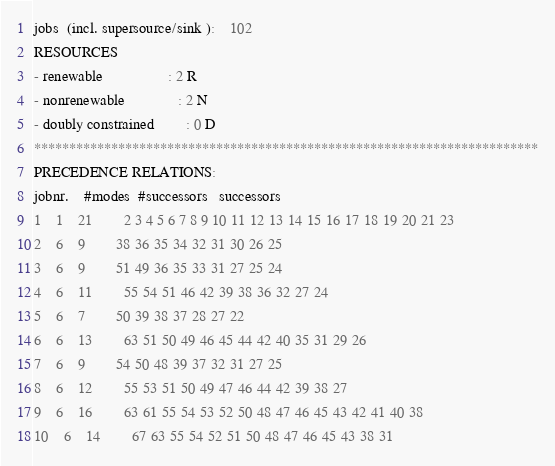<code> <loc_0><loc_0><loc_500><loc_500><_ObjectiveC_>jobs  (incl. supersource/sink ):	102
RESOURCES
- renewable                 : 2 R
- nonrenewable              : 2 N
- doubly constrained        : 0 D
************************************************************************
PRECEDENCE RELATIONS:
jobnr.    #modes  #successors   successors
1	1	21		2 3 4 5 6 7 8 9 10 11 12 13 14 15 16 17 18 19 20 21 23 
2	6	9		38 36 35 34 32 31 30 26 25 
3	6	9		51 49 36 35 33 31 27 25 24 
4	6	11		55 54 51 46 42 39 38 36 32 27 24 
5	6	7		50 39 38 37 28 27 22 
6	6	13		63 51 50 49 46 45 44 42 40 35 31 29 26 
7	6	9		54 50 48 39 37 32 31 27 25 
8	6	12		55 53 51 50 49 47 46 44 42 39 38 27 
9	6	16		63 61 55 54 53 52 50 48 47 46 45 43 42 41 40 38 
10	6	14		67 63 55 54 52 51 50 48 47 46 45 43 38 31 </code> 